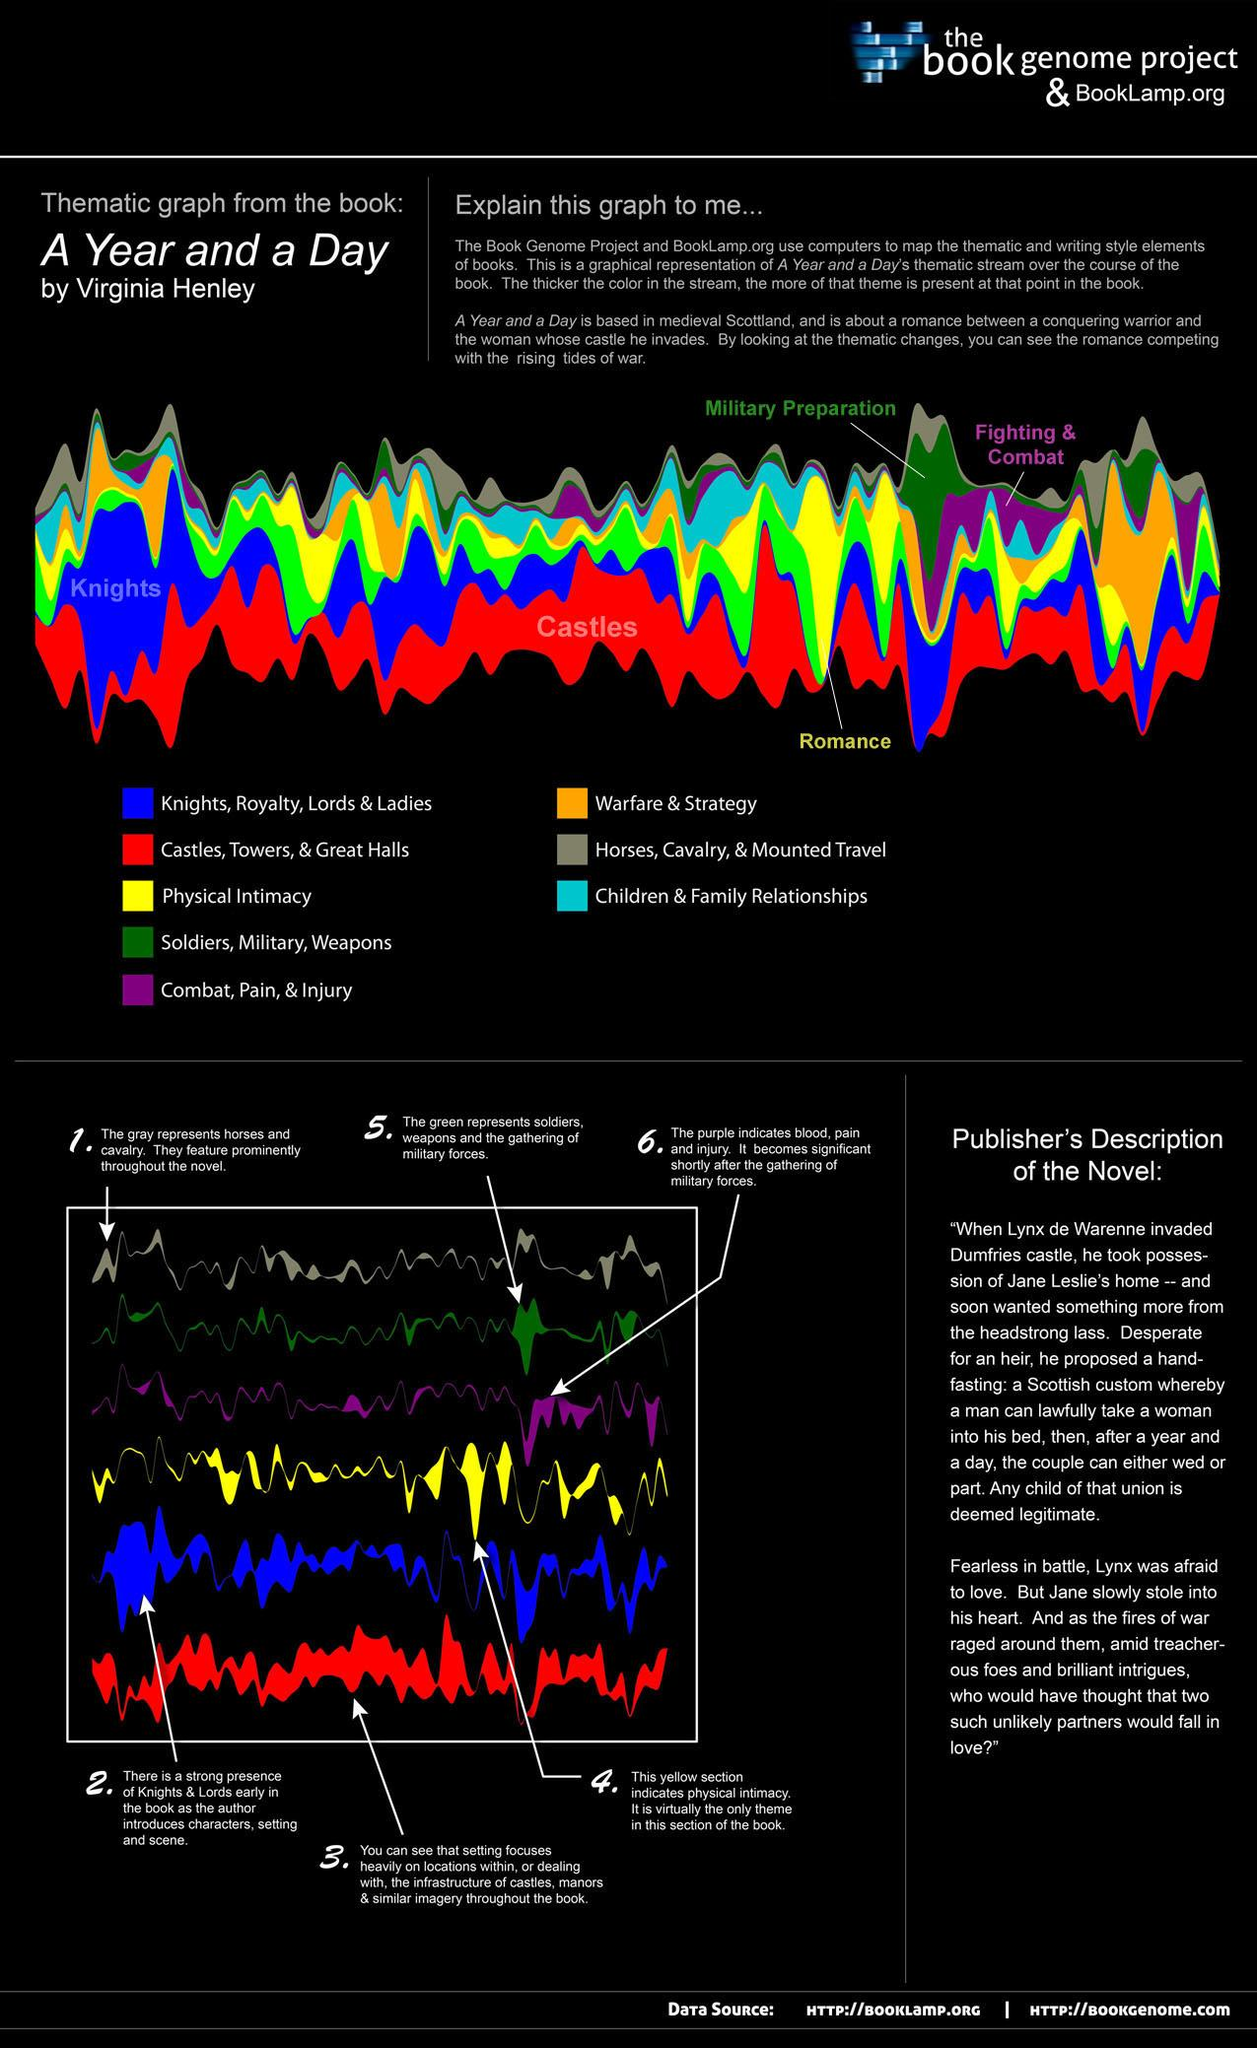Mention a couple of crucial points in this snapshot. Red, orange, and green were once used to represent warfare and strategy. However, orange was the color that was primarily used for this purpose. In the past, yellow was the color that represented physical intimacy. 